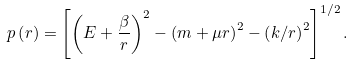Convert formula to latex. <formula><loc_0><loc_0><loc_500><loc_500>p \left ( r \right ) = \left [ \left ( E + \frac { \beta } { r } \right ) ^ { 2 } - \left ( m + \mu r \right ) ^ { 2 } - \left ( k / r \right ) ^ { 2 } \right ] ^ { 1 / 2 } .</formula> 